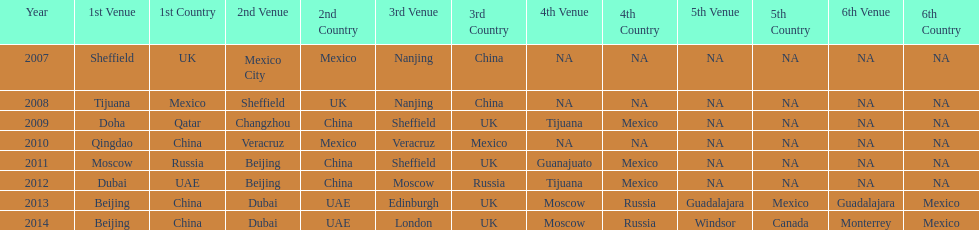In list of venues, how many years was beijing above moscow (1st venue is above 2nd venue, etc)? 3. 